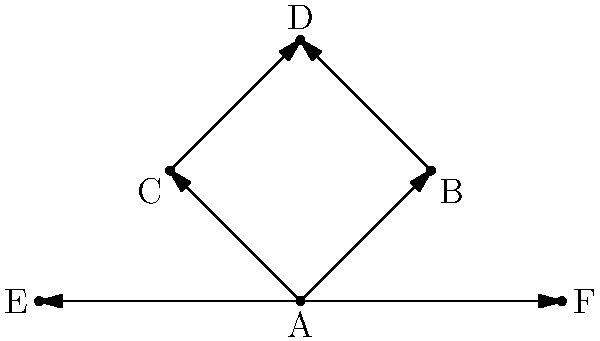In the context of analyzing character relationships in novels using network graphs, what type of centrality measure would be most appropriate to identify the character with the highest influence or importance in the story, based on the graph shown? To determine the most appropriate centrality measure for identifying the character with the highest influence or importance in the story, we need to consider the structure of the given network graph and the various centrality measures available:

1. Degree Centrality: This measures the number of direct connections a node has. In this graph, node A has the highest degree centrality with 5 connections.

2. Betweenness Centrality: This measures how often a node acts as a bridge along the shortest path between two other nodes. Node A would have the highest betweenness centrality as it connects all other nodes.

3. Closeness Centrality: This measures how close a node is to all other nodes in the network. Again, node A would have the highest closeness centrality due to its central position.

4. Eigenvector Centrality: This measures a node's influence based on the importance of its connections. Node A would likely have the highest eigenvector centrality due to its numerous connections.

5. PageRank: Similar to eigenvector centrality, but takes into account the direction of connections. Node A would have the highest PageRank due to its incoming and outgoing connections.

Considering the structure of this network, where character A is clearly central and connects to all other characters, the most appropriate measure would be Eigenvector Centrality or PageRank. These measures not only account for the number of connections but also the importance of those connections, which is crucial in analyzing character influence in a narrative context.

Given that the graph shows directed edges (arrows), PageRank would be the most suitable choice as it considers the direction of relationships, which can be particularly relevant in analyzing the flow of influence or information in a story.
Answer: PageRank 